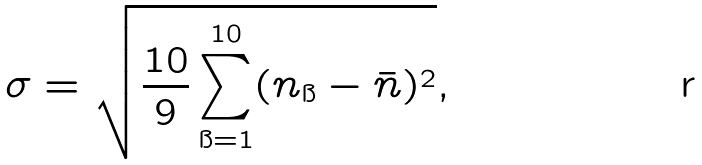Convert formula to latex. <formula><loc_0><loc_0><loc_500><loc_500>\sigma = \sqrt { \frac { 1 0 } { 9 } \sum _ { \i = 1 } ^ { 1 0 } ( n _ { \i } - \bar { n } ) ^ { 2 } } ,</formula> 